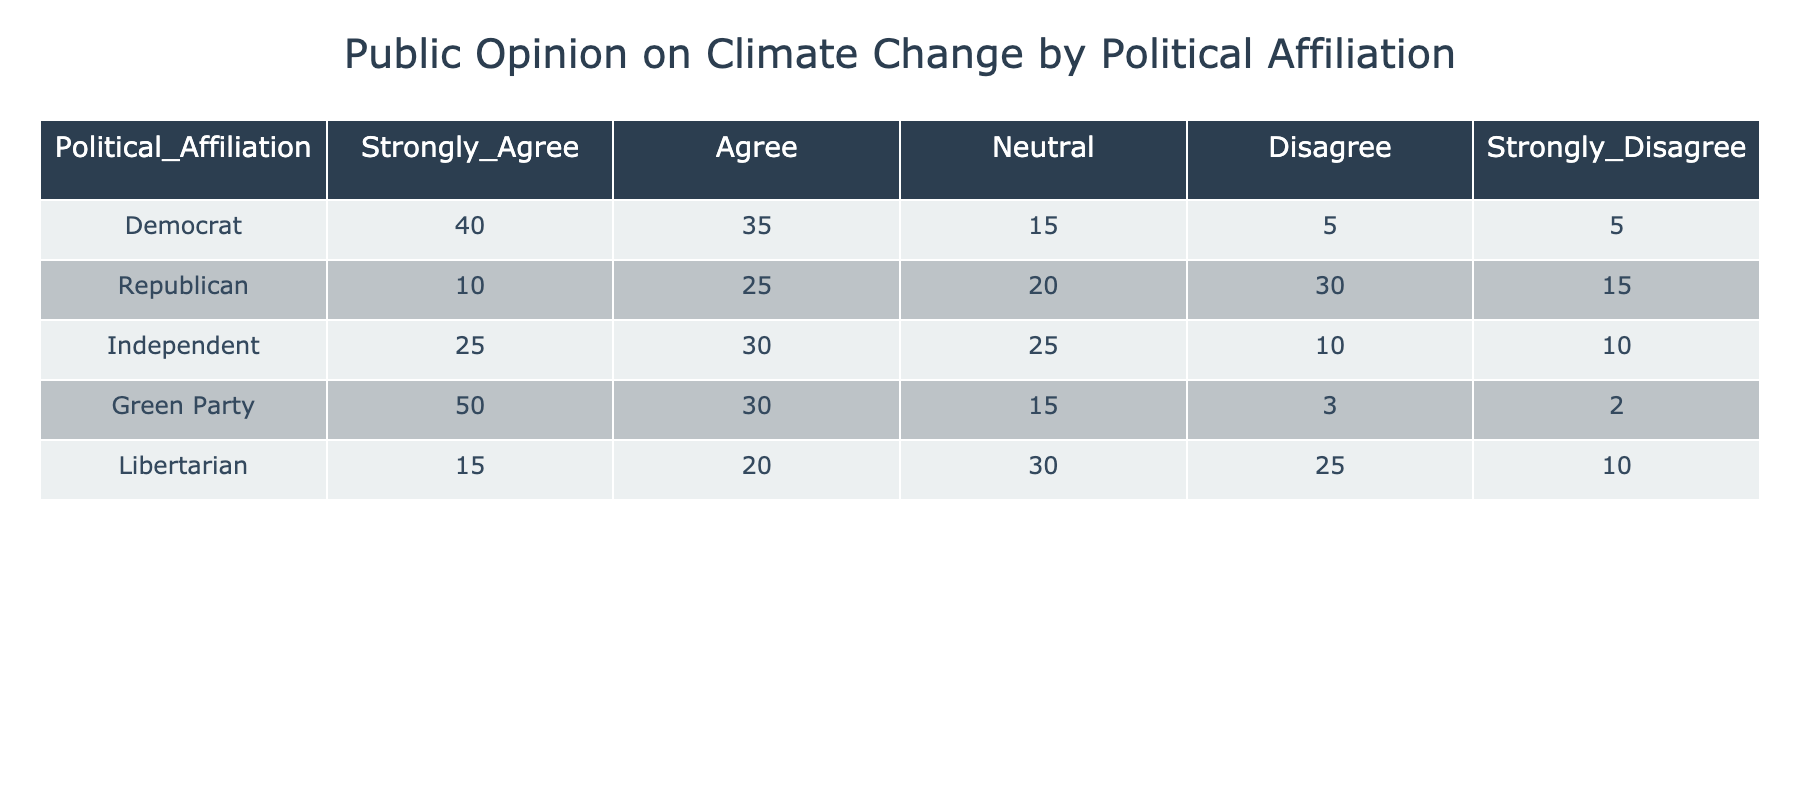What percentage of Democrats strongly agree with the idea of climate change? From the table, 40 Democrats strongly agree. To find the percentage, we compare it to the total Democrat responses, which is 40 + 35 + 15 + 5 + 5 = 100. Thus, the percentage is (40/100) * 100 = 40%.
Answer: 40% How many Independents agree or strongly agree with climate change? There are 30 Independent respondents who agree and 25 who strongly agree. We add these two values: 30 + 25 = 55.
Answer: 55 Is it true that more Green Party members strongly agree with climate change than Libertarians? Referring to the table, 50 Green Party members strongly agree, while 15 Libertarians strongly agree. Since 50 is greater than 15, the statement is true.
Answer: Yes What is the total number of negative responses (Disagree and Strongly Disagree) for Republicans? The Republican negative responses are 30 (Disagree) + 15 (Strongly Disagree) = 45.
Answer: 45 What is the overall average percentage of respondents across all affiliations who agree with climate change? To find the average for agreeing, we take the sums of agree responses: 35 (Democrat) + 25 (Republican) + 30 (Independent) + 30 (Green Party) + 20 (Libertarian) = 140. We have 5 groups, so the average is 140 / 5 = 28%.
Answer: 28% Which political group has the highest percentage of respondents that are Neutral on climate change? Looking at the Neutral values, Democrats have 15, Republicans 20, Independents 25, Green Party 15, and Libertarians 30. The highest percentage is from Libertarians at 30.
Answer: Libertarian What is the difference in the percentage of Democrats and Republicans who strongly agree with the idea of climate change? Democrats strongly agree at 40% and Republicans at 10%. The difference is 40% - 10% = 30%.
Answer: 30% In total, how many respondents from all affiliations disagree with climate change? Adding up disagreeing responses: 5 (Democrat) + 30 (Republican) + 10 (Independent) + 3 (Green Party) + 25 (Libertarian) = 73.
Answer: 73 